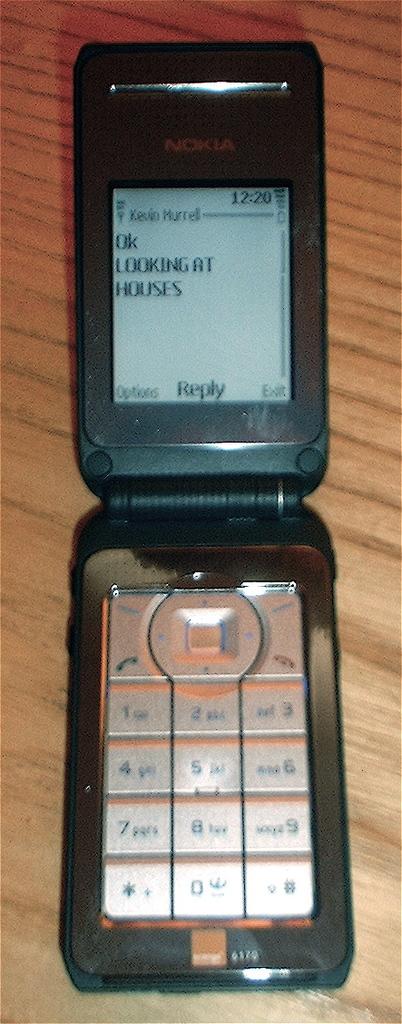What brand is this phone?
Offer a terse response. Nokia. What time is it on this phone?
Ensure brevity in your answer.  12:20. 